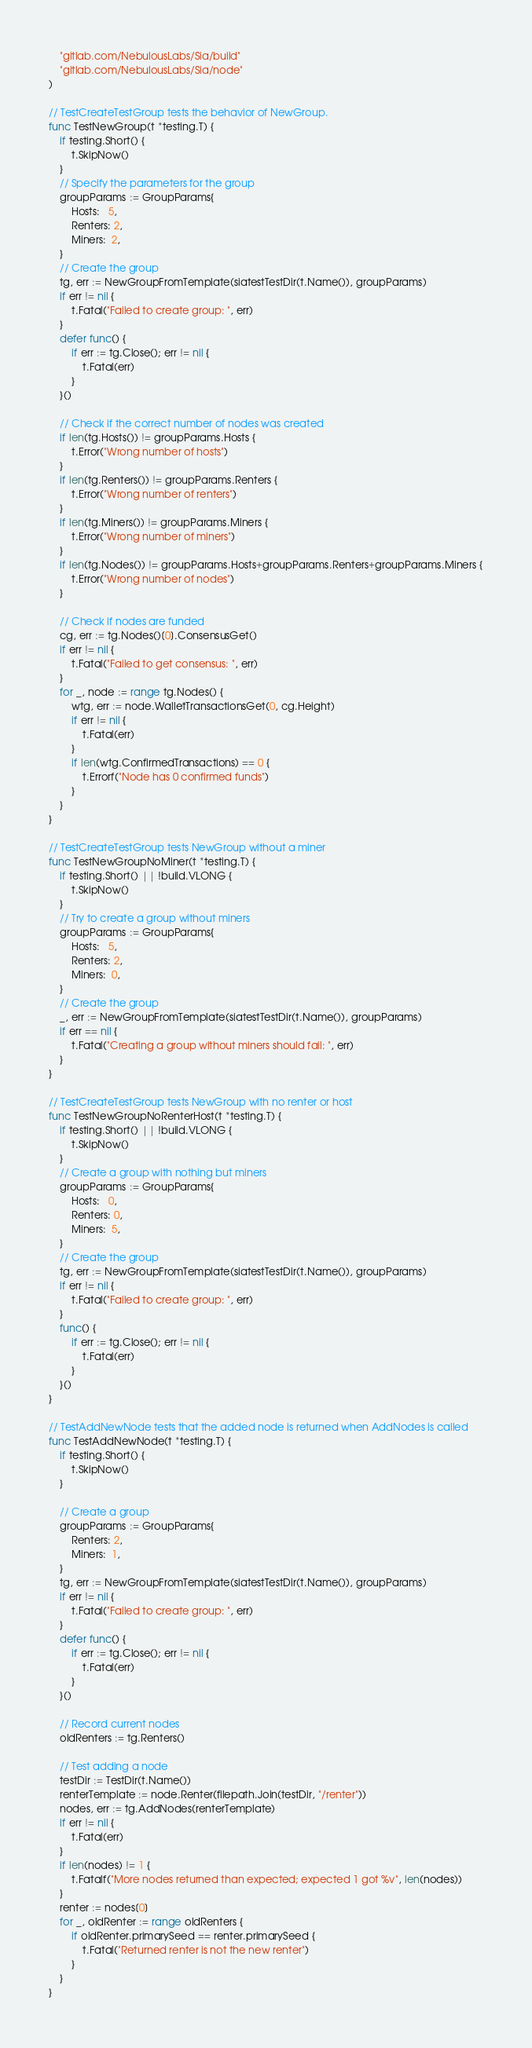Convert code to text. <code><loc_0><loc_0><loc_500><loc_500><_Go_>	"gitlab.com/NebulousLabs/Sia/build"
	"gitlab.com/NebulousLabs/Sia/node"
)

// TestCreateTestGroup tests the behavior of NewGroup.
func TestNewGroup(t *testing.T) {
	if testing.Short() {
		t.SkipNow()
	}
	// Specify the parameters for the group
	groupParams := GroupParams{
		Hosts:   5,
		Renters: 2,
		Miners:  2,
	}
	// Create the group
	tg, err := NewGroupFromTemplate(siatestTestDir(t.Name()), groupParams)
	if err != nil {
		t.Fatal("Failed to create group: ", err)
	}
	defer func() {
		if err := tg.Close(); err != nil {
			t.Fatal(err)
		}
	}()

	// Check if the correct number of nodes was created
	if len(tg.Hosts()) != groupParams.Hosts {
		t.Error("Wrong number of hosts")
	}
	if len(tg.Renters()) != groupParams.Renters {
		t.Error("Wrong number of renters")
	}
	if len(tg.Miners()) != groupParams.Miners {
		t.Error("Wrong number of miners")
	}
	if len(tg.Nodes()) != groupParams.Hosts+groupParams.Renters+groupParams.Miners {
		t.Error("Wrong number of nodes")
	}

	// Check if nodes are funded
	cg, err := tg.Nodes()[0].ConsensusGet()
	if err != nil {
		t.Fatal("Failed to get consensus: ", err)
	}
	for _, node := range tg.Nodes() {
		wtg, err := node.WalletTransactionsGet(0, cg.Height)
		if err != nil {
			t.Fatal(err)
		}
		if len(wtg.ConfirmedTransactions) == 0 {
			t.Errorf("Node has 0 confirmed funds")
		}
	}
}

// TestCreateTestGroup tests NewGroup without a miner
func TestNewGroupNoMiner(t *testing.T) {
	if testing.Short() || !build.VLONG {
		t.SkipNow()
	}
	// Try to create a group without miners
	groupParams := GroupParams{
		Hosts:   5,
		Renters: 2,
		Miners:  0,
	}
	// Create the group
	_, err := NewGroupFromTemplate(siatestTestDir(t.Name()), groupParams)
	if err == nil {
		t.Fatal("Creating a group without miners should fail: ", err)
	}
}

// TestCreateTestGroup tests NewGroup with no renter or host
func TestNewGroupNoRenterHost(t *testing.T) {
	if testing.Short() || !build.VLONG {
		t.SkipNow()
	}
	// Create a group with nothing but miners
	groupParams := GroupParams{
		Hosts:   0,
		Renters: 0,
		Miners:  5,
	}
	// Create the group
	tg, err := NewGroupFromTemplate(siatestTestDir(t.Name()), groupParams)
	if err != nil {
		t.Fatal("Failed to create group: ", err)
	}
	func() {
		if err := tg.Close(); err != nil {
			t.Fatal(err)
		}
	}()
}

// TestAddNewNode tests that the added node is returned when AddNodes is called
func TestAddNewNode(t *testing.T) {
	if testing.Short() {
		t.SkipNow()
	}

	// Create a group
	groupParams := GroupParams{
		Renters: 2,
		Miners:  1,
	}
	tg, err := NewGroupFromTemplate(siatestTestDir(t.Name()), groupParams)
	if err != nil {
		t.Fatal("Failed to create group: ", err)
	}
	defer func() {
		if err := tg.Close(); err != nil {
			t.Fatal(err)
		}
	}()

	// Record current nodes
	oldRenters := tg.Renters()

	// Test adding a node
	testDir := TestDir(t.Name())
	renterTemplate := node.Renter(filepath.Join(testDir, "/renter"))
	nodes, err := tg.AddNodes(renterTemplate)
	if err != nil {
		t.Fatal(err)
	}
	if len(nodes) != 1 {
		t.Fatalf("More nodes returned than expected; expected 1 got %v", len(nodes))
	}
	renter := nodes[0]
	for _, oldRenter := range oldRenters {
		if oldRenter.primarySeed == renter.primarySeed {
			t.Fatal("Returned renter is not the new renter")
		}
	}
}
</code> 